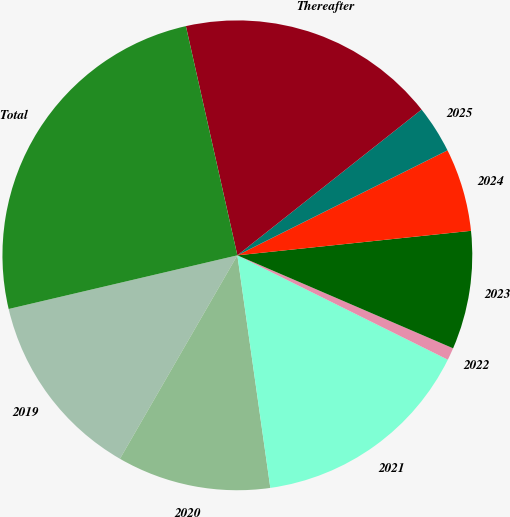Convert chart to OTSL. <chart><loc_0><loc_0><loc_500><loc_500><pie_chart><fcel>2019<fcel>2020<fcel>2021<fcel>2022<fcel>2023<fcel>2024<fcel>2025<fcel>Thereafter<fcel>Total<nl><fcel>13.0%<fcel>10.57%<fcel>15.43%<fcel>0.85%<fcel>8.14%<fcel>5.71%<fcel>3.28%<fcel>17.86%<fcel>25.15%<nl></chart> 